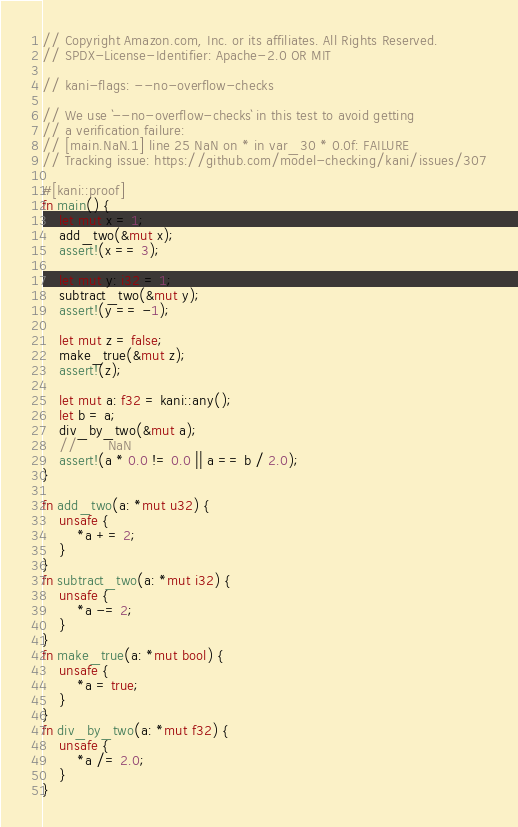Convert code to text. <code><loc_0><loc_0><loc_500><loc_500><_Rust_>// Copyright Amazon.com, Inc. or its affiliates. All Rights Reserved.
// SPDX-License-Identifier: Apache-2.0 OR MIT

// kani-flags: --no-overflow-checks

// We use `--no-overflow-checks` in this test to avoid getting
// a verification failure:
// [main.NaN.1] line 25 NaN on * in var_30 * 0.0f: FAILURE
// Tracking issue: https://github.com/model-checking/kani/issues/307

#[kani::proof]
fn main() {
    let mut x = 1;
    add_two(&mut x);
    assert!(x == 3);

    let mut y: i32 = 1;
    subtract_two(&mut y);
    assert!(y == -1);

    let mut z = false;
    make_true(&mut z);
    assert!(z);

    let mut a: f32 = kani::any();
    let b = a;
    div_by_two(&mut a);
    //       NaN
    assert!(a * 0.0 != 0.0 || a == b / 2.0);
}

fn add_two(a: *mut u32) {
    unsafe {
        *a += 2;
    }
}
fn subtract_two(a: *mut i32) {
    unsafe {
        *a -= 2;
    }
}
fn make_true(a: *mut bool) {
    unsafe {
        *a = true;
    }
}
fn div_by_two(a: *mut f32) {
    unsafe {
        *a /= 2.0;
    }
}
</code> 